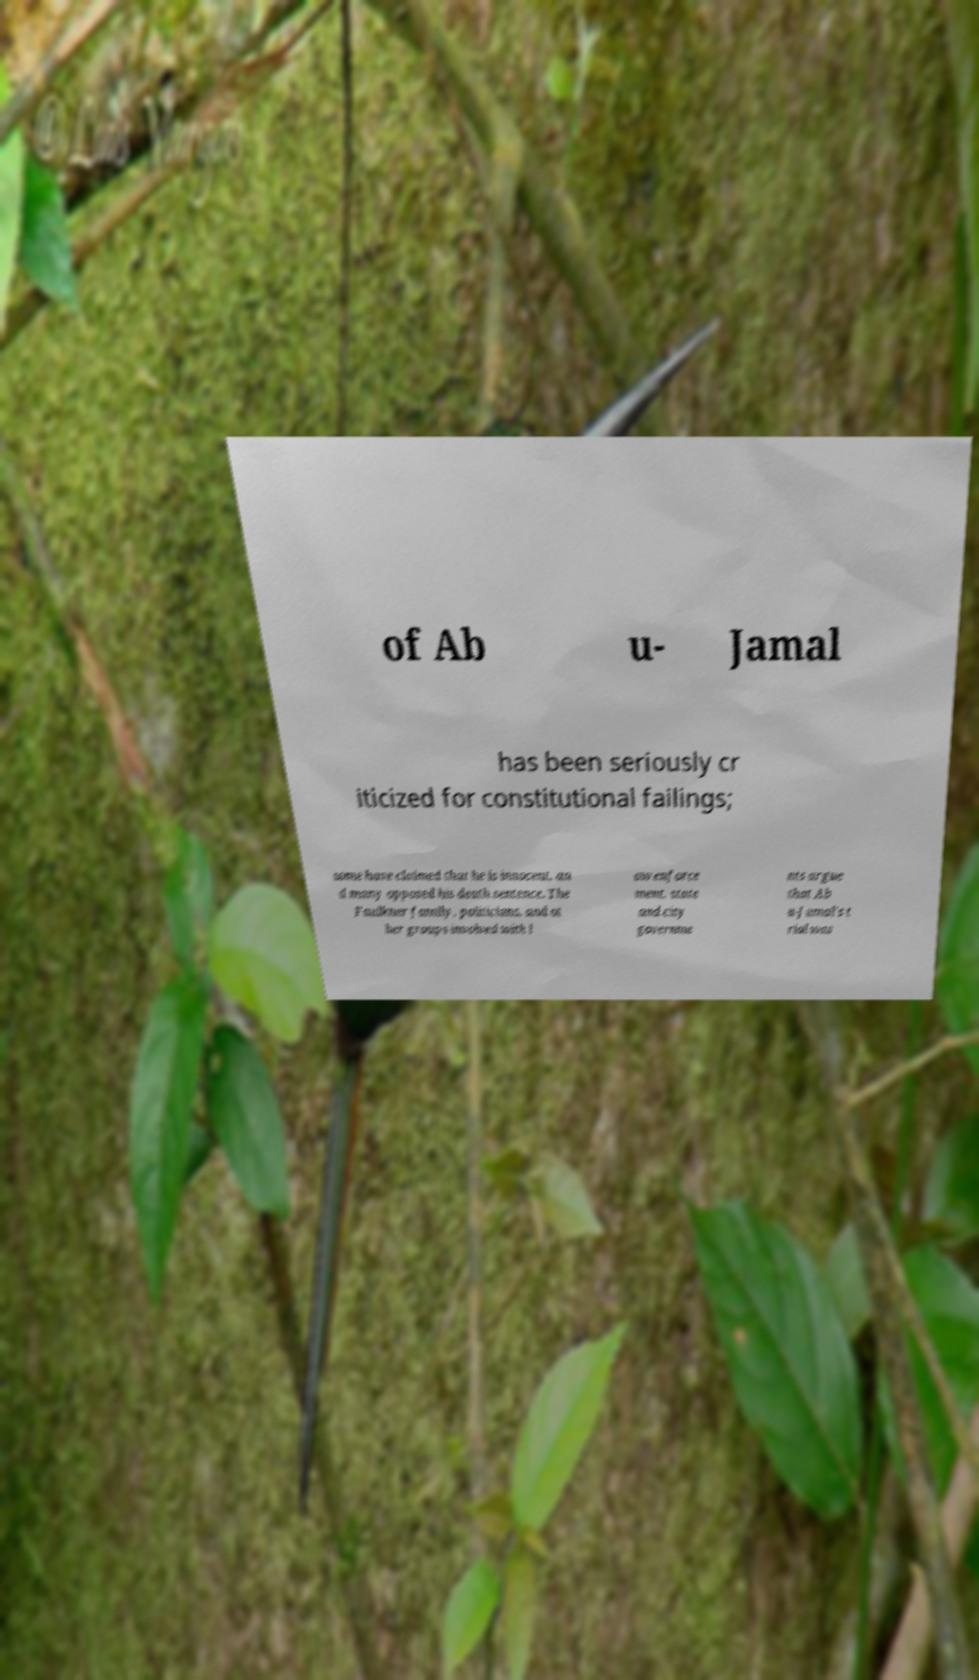Please identify and transcribe the text found in this image. of Ab u- Jamal has been seriously cr iticized for constitutional failings; some have claimed that he is innocent, an d many opposed his death sentence. The Faulkner family, politicians, and ot her groups involved with l aw enforce ment, state and city governme nts argue that Ab u-Jamal's t rial was 